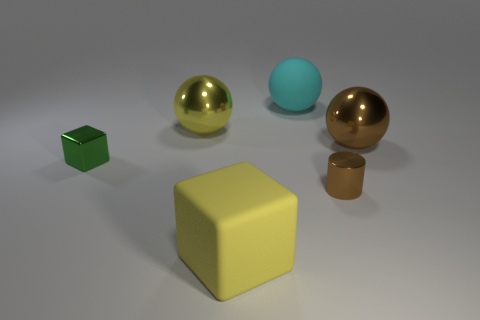Subtract all big metallic balls. How many balls are left? 1 Add 1 small purple metallic balls. How many objects exist? 7 Subtract 2 balls. How many balls are left? 1 Subtract all yellow blocks. How many blocks are left? 1 Add 4 balls. How many balls exist? 7 Subtract 0 red cylinders. How many objects are left? 6 Subtract all cylinders. How many objects are left? 5 Subtract all red blocks. Subtract all brown cylinders. How many blocks are left? 2 Subtract all blue cubes. How many yellow balls are left? 1 Subtract all small yellow rubber spheres. Subtract all green metallic things. How many objects are left? 5 